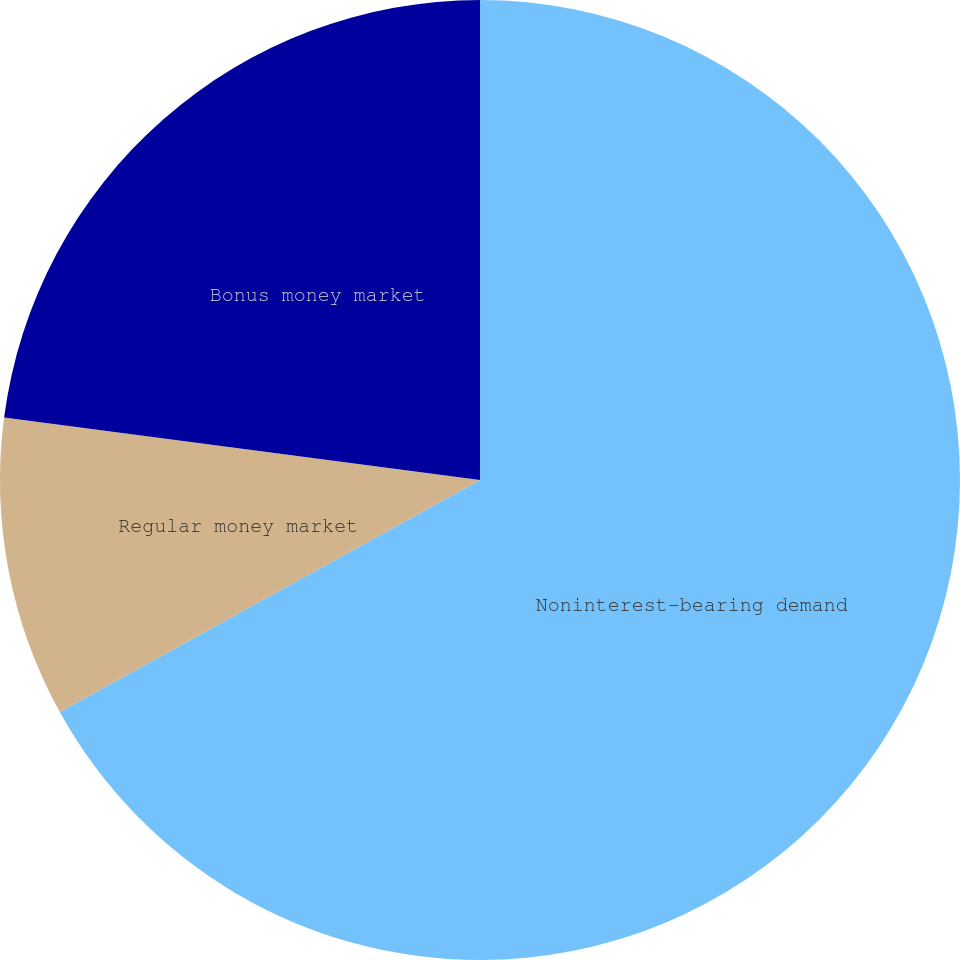<chart> <loc_0><loc_0><loc_500><loc_500><pie_chart><fcel>Noninterest-bearing demand<fcel>Regular money market<fcel>Bonus money market<nl><fcel>66.97%<fcel>10.11%<fcel>22.92%<nl></chart> 